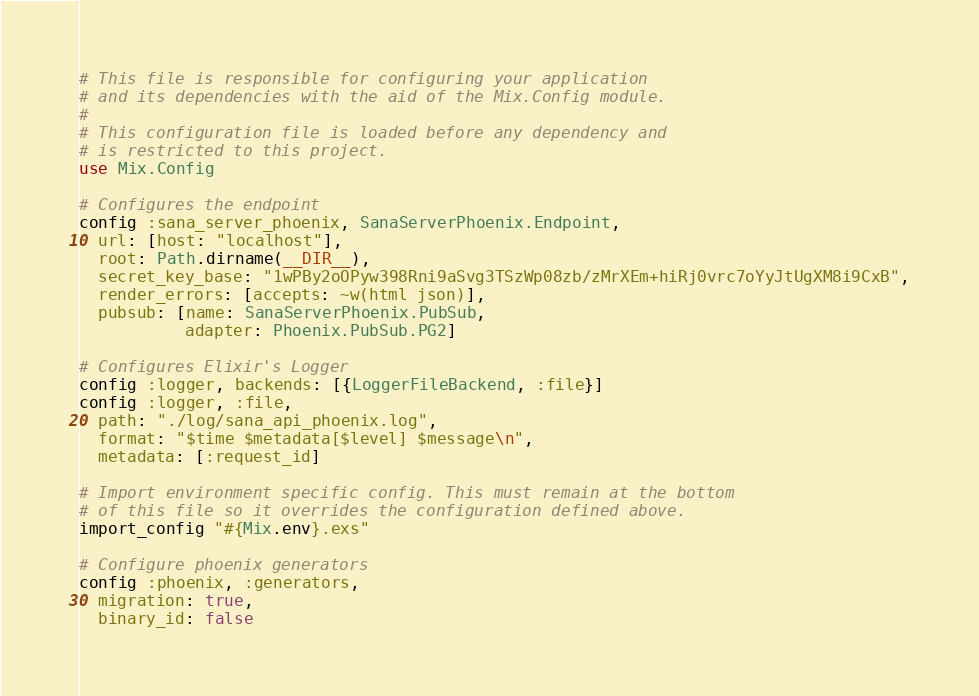<code> <loc_0><loc_0><loc_500><loc_500><_Elixir_># This file is responsible for configuring your application
# and its dependencies with the aid of the Mix.Config module.
#
# This configuration file is loaded before any dependency and
# is restricted to this project.
use Mix.Config

# Configures the endpoint
config :sana_server_phoenix, SanaServerPhoenix.Endpoint,
  url: [host: "localhost"],
  root: Path.dirname(__DIR__),
  secret_key_base: "1wPBy2oOPyw398Rni9aSvg3TSzWp08zb/zMrXEm+hiRj0vrc7oYyJtUgXM8i9CxB",
  render_errors: [accepts: ~w(html json)],
  pubsub: [name: SanaServerPhoenix.PubSub,
           adapter: Phoenix.PubSub.PG2]

# Configures Elixir's Logger
config :logger, backends: [{LoggerFileBackend, :file}]
config :logger, :file,
  path: "./log/sana_api_phoenix.log",
  format: "$time $metadata[$level] $message\n",
  metadata: [:request_id]

# Import environment specific config. This must remain at the bottom
# of this file so it overrides the configuration defined above.
import_config "#{Mix.env}.exs"

# Configure phoenix generators
config :phoenix, :generators,
  migration: true,
  binary_id: false
</code> 